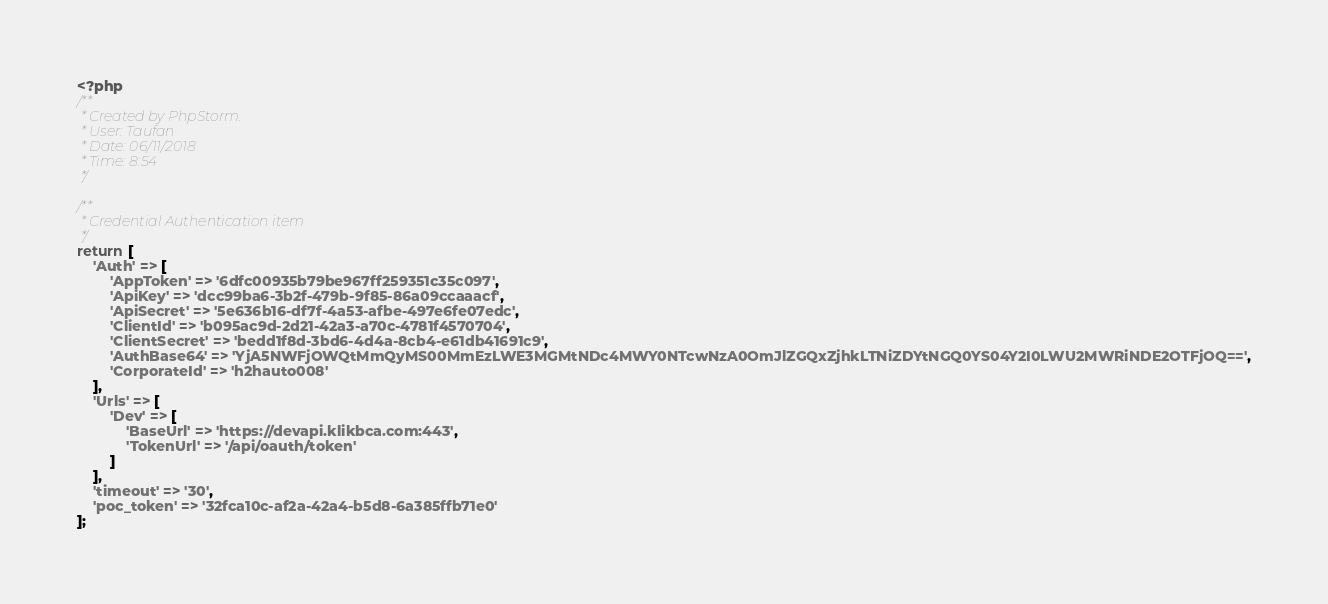<code> <loc_0><loc_0><loc_500><loc_500><_PHP_><?php
/**
 * Created by PhpStorm.
 * User: Taufan
 * Date: 06/11/2018
 * Time: 8:54
 */

/**
 * Credential Authentication item
 */
return [
    'Auth' => [
        'AppToken' => '6dfc00935b79be967ff259351c35c097',
        'ApiKey' => 'dcc99ba6-3b2f-479b-9f85-86a09ccaaacf',
        'ApiSecret' => '5e636b16-df7f-4a53-afbe-497e6fe07edc',
        'ClientId' => 'b095ac9d-2d21-42a3-a70c-4781f4570704',
        'ClientSecret' => 'bedd1f8d-3bd6-4d4a-8cb4-e61db41691c9',
        'AuthBase64' => 'YjA5NWFjOWQtMmQyMS00MmEzLWE3MGMtNDc4MWY0NTcwNzA0OmJlZGQxZjhkLTNiZDYtNGQ0YS04Y2I0LWU2MWRiNDE2OTFjOQ==',
        'CorporateId' => 'h2hauto008'
    ],
    'Urls' => [
        'Dev' => [
            'BaseUrl' => 'https://devapi.klikbca.com:443',
            'TokenUrl' => '/api/oauth/token'
        ]
    ],
    'timeout' => '30',
	'poc_token' => '32fca10c-af2a-42a4-b5d8-6a385ffb71e0'
];</code> 